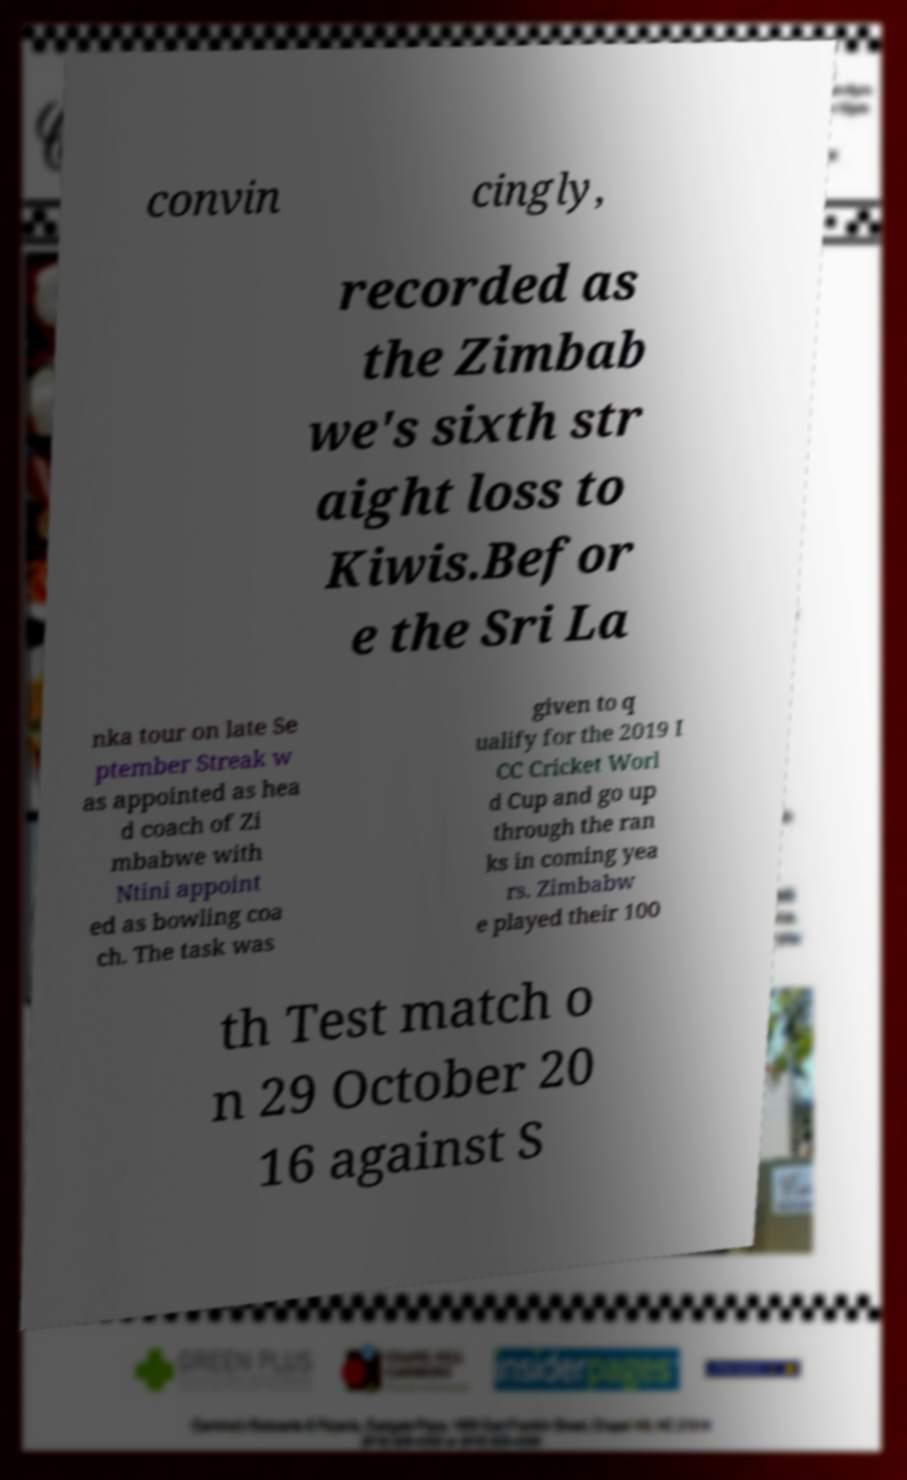Can you accurately transcribe the text from the provided image for me? convin cingly, recorded as the Zimbab we's sixth str aight loss to Kiwis.Befor e the Sri La nka tour on late Se ptember Streak w as appointed as hea d coach of Zi mbabwe with Ntini appoint ed as bowling coa ch. The task was given to q ualify for the 2019 I CC Cricket Worl d Cup and go up through the ran ks in coming yea rs. Zimbabw e played their 100 th Test match o n 29 October 20 16 against S 